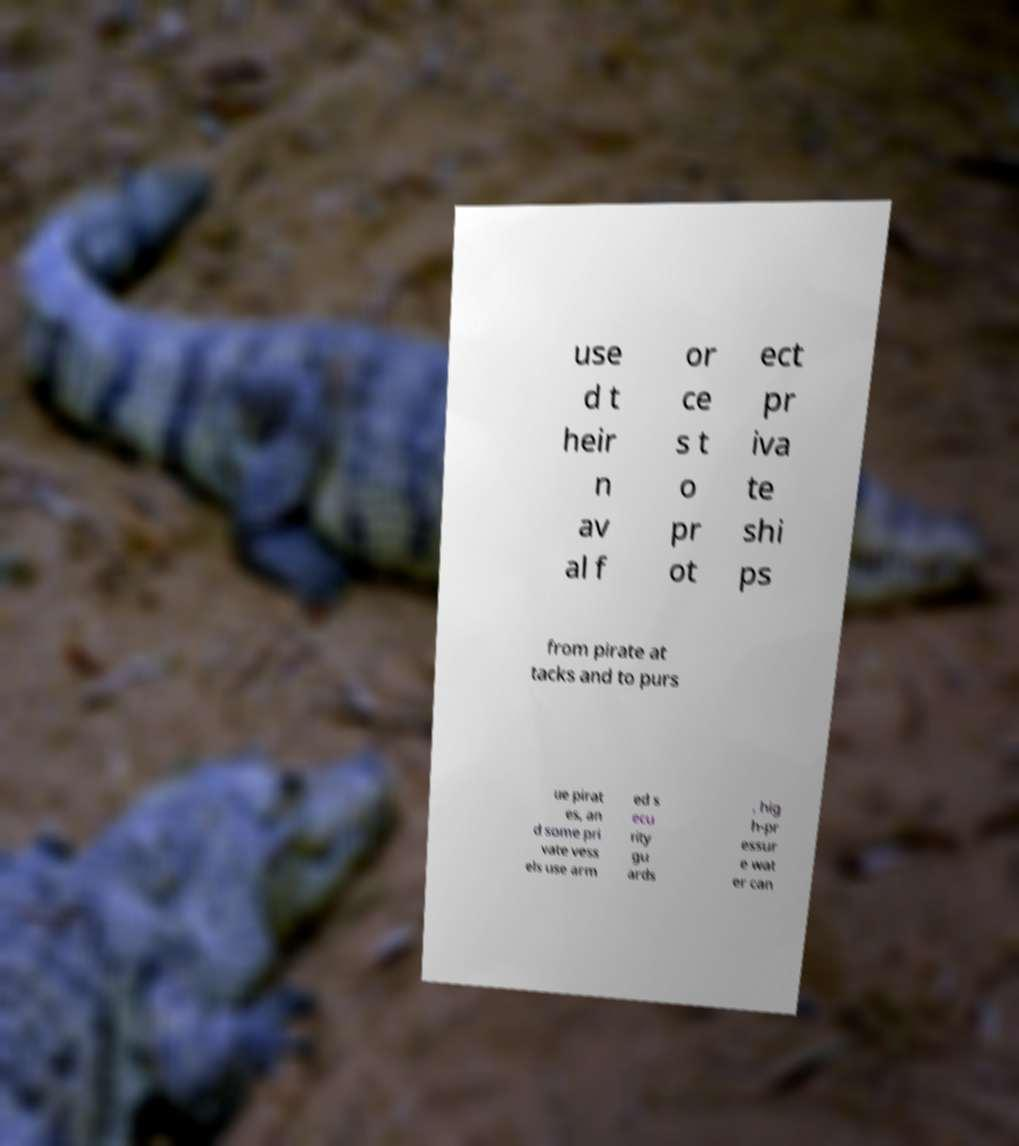Can you read and provide the text displayed in the image?This photo seems to have some interesting text. Can you extract and type it out for me? use d t heir n av al f or ce s t o pr ot ect pr iva te shi ps from pirate at tacks and to purs ue pirat es, an d some pri vate vess els use arm ed s ecu rity gu ards , hig h-pr essur e wat er can 